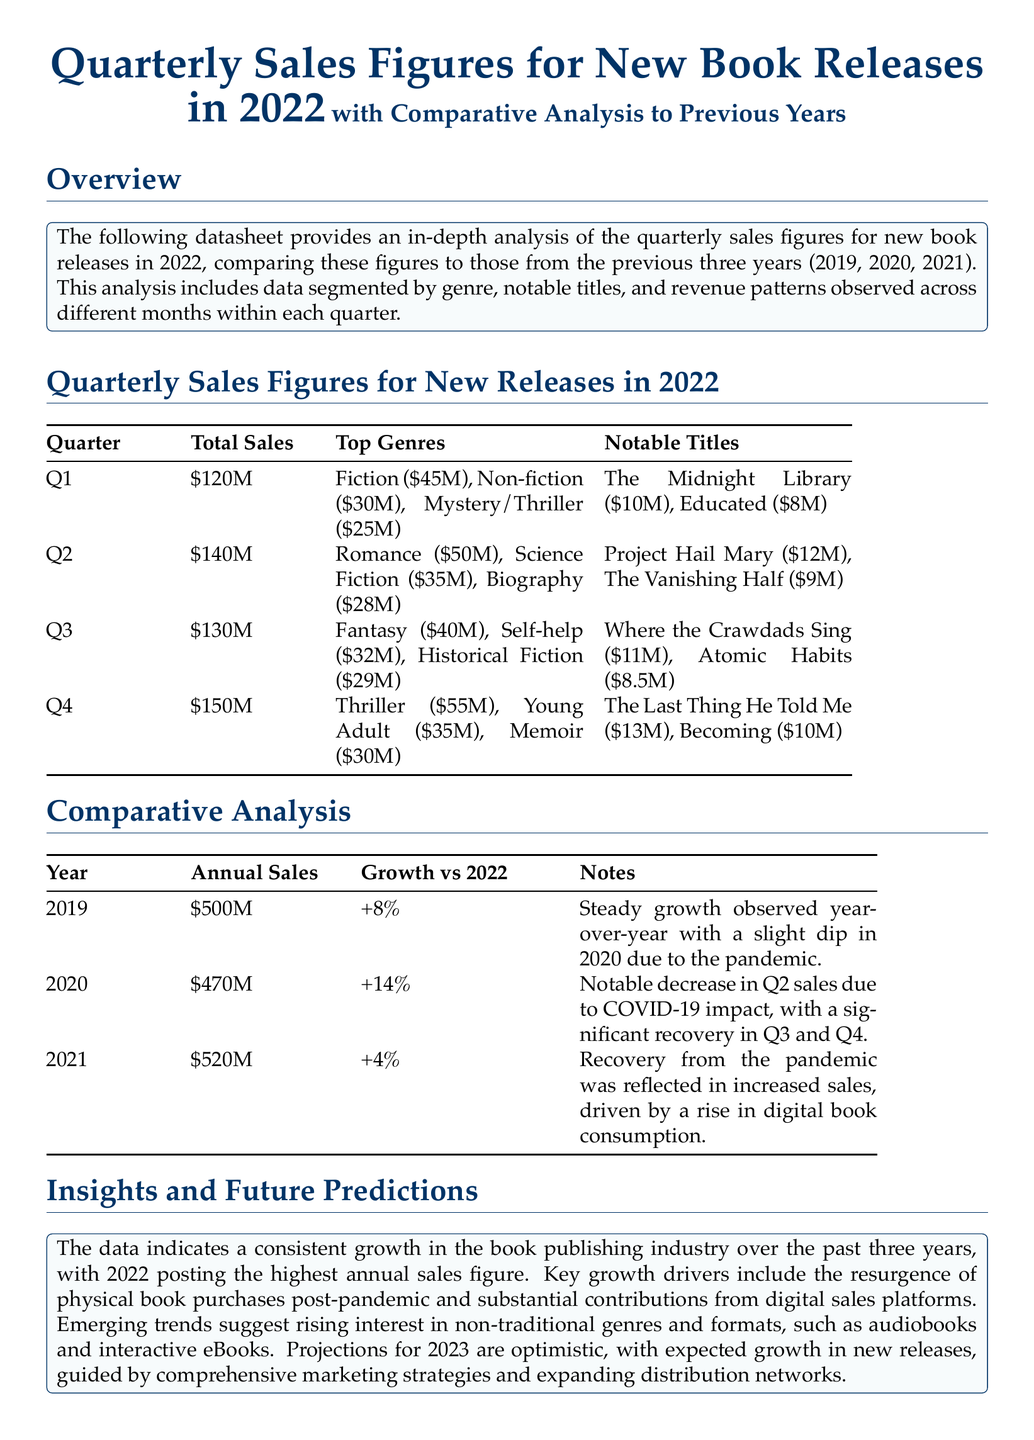What was the total sales for Q2 in 2022? The total sales figure for Q2 is explicitly stated in the document.
Answer: $140M Which genre had the highest sales in Q4 of 2022? The top genres section for Q4 lists their revenues, allowing us to determine which had the highest.
Answer: Thriller How much did "Where the Crawdads Sing" earn in Q3 of 2022? The notable titles listed in Q3 provides specific revenue figures for that title.
Answer: $11M What was the annual sales for 2021? The annual sales figures for each year are presented in the comparative analysis section.
Answer: $520M What percentage growth was recorded for 2019 compared to 2022? The comparative analysis table shows growth percentages for each year compared to 2022.
Answer: +8% Which quarter had the lowest total sales in 2022? By analyzing the total sales figures for each quarter, we can identify the lowest one.
Answer: Q1 What notable title earned $10M in Q4 of 2022? The notable titles in Q4 section lists specific titles and their corresponding earnings.
Answer: The Last Thing He Told Me In which genre was there a sales figure of $25M in Q1 of 2022? The top genres section for Q1 includes sales figures, allowing us to match the figure to its genre.
Answer: Mystery/Thriller Which year had a notable decrease in Q2 sales due to COVID-19? The notes in the comparative analysis section indicate the year with a significant decrease linked to the pandemic.
Answer: 2020 